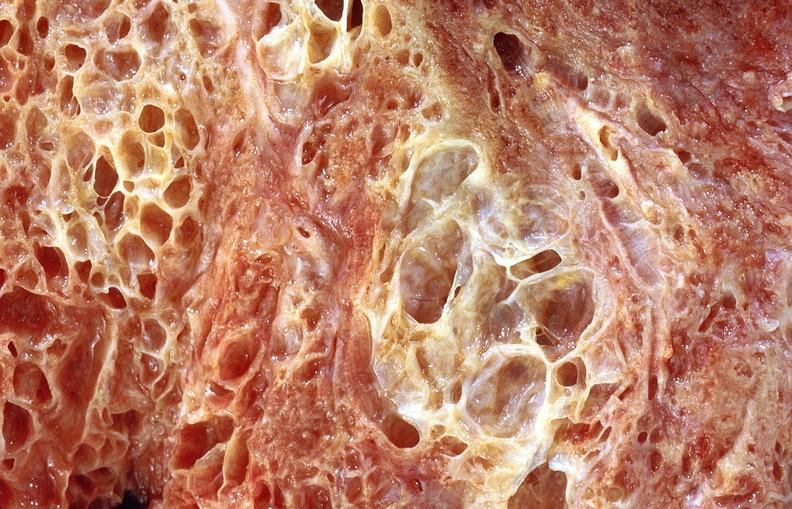what does this image show?
Answer the question using a single word or phrase. Lung fibrosis 